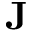<formula> <loc_0><loc_0><loc_500><loc_500>J</formula> 